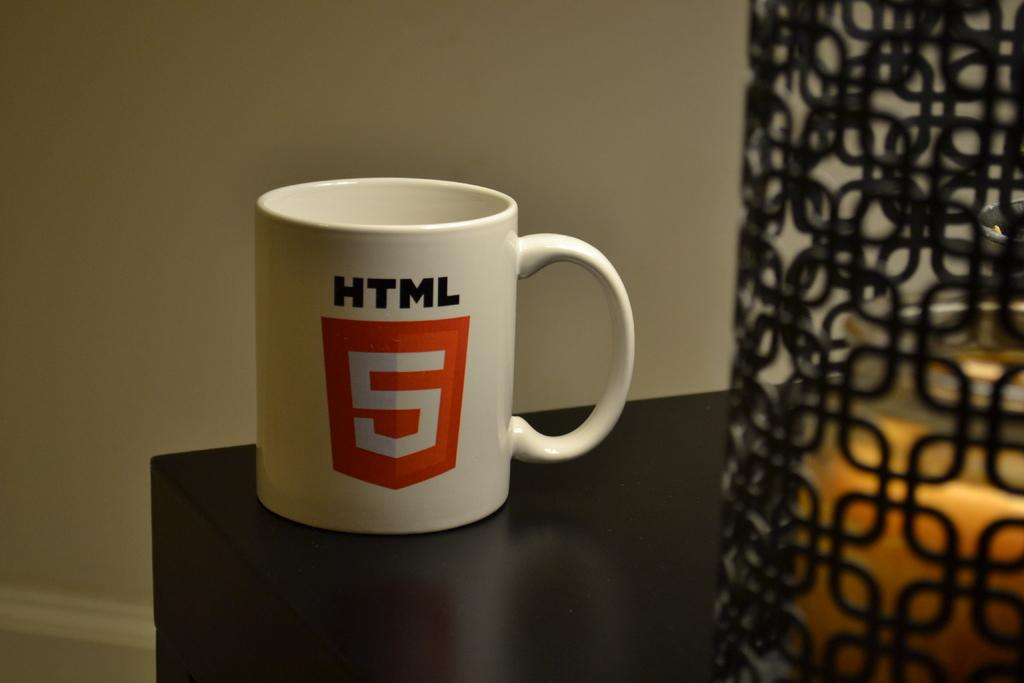<image>
Give a short and clear explanation of the subsequent image. a white mug with HTML and 5 on it 